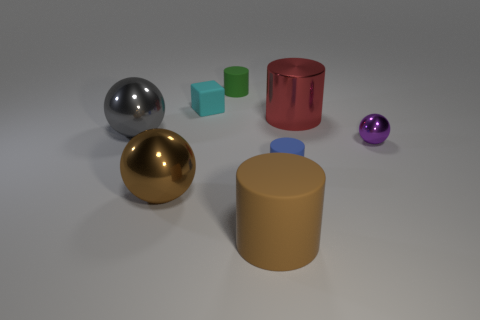Add 2 green matte cubes. How many objects exist? 10 Subtract all balls. How many objects are left? 5 Add 2 tiny cubes. How many tiny cubes exist? 3 Subtract 1 brown cylinders. How many objects are left? 7 Subtract all red metallic cylinders. Subtract all blue cylinders. How many objects are left? 6 Add 8 big gray objects. How many big gray objects are left? 9 